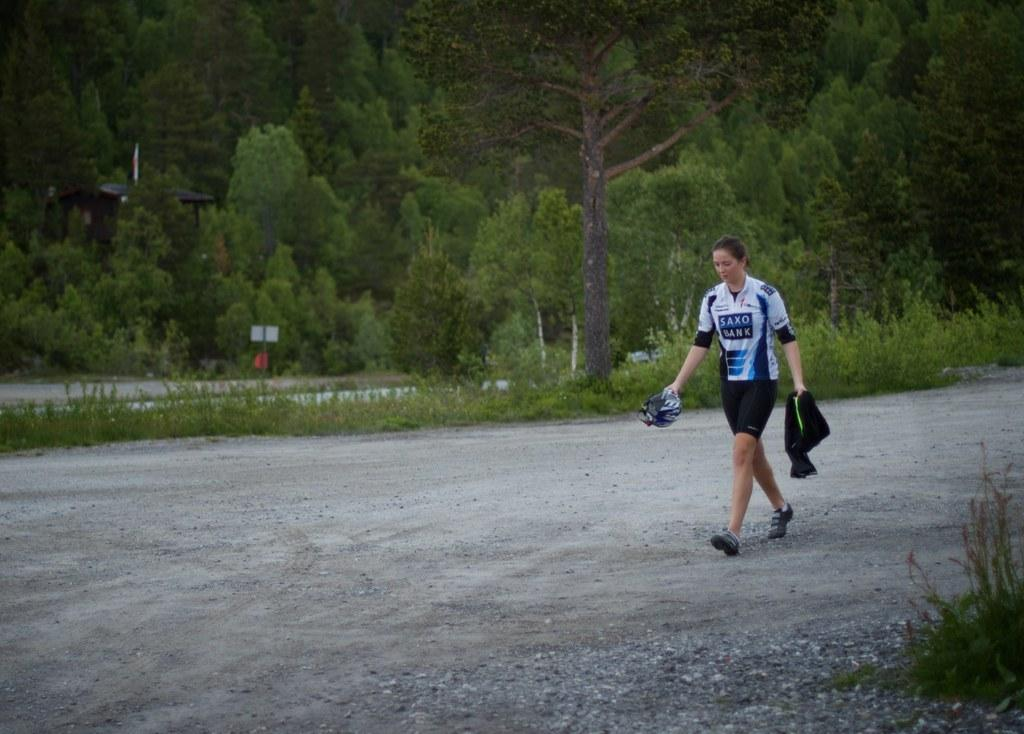What is the person in the image holding? The person is holding objects in the image. What can be seen beneath the person's feet? The ground is visible in the image. What type of vegetation is present in the image? There is grass, plants, and trees in the image. What structure can be seen in the background? There is a shed in the image. What is attached to the pole in the image? There is a board attached to the pole in the image. What type of cakes are being served at the insurance meeting in the image? There is no mention of cakes or an insurance meeting in the image. 